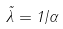Convert formula to latex. <formula><loc_0><loc_0><loc_500><loc_500>\tilde { \lambda } = 1 / \alpha</formula> 